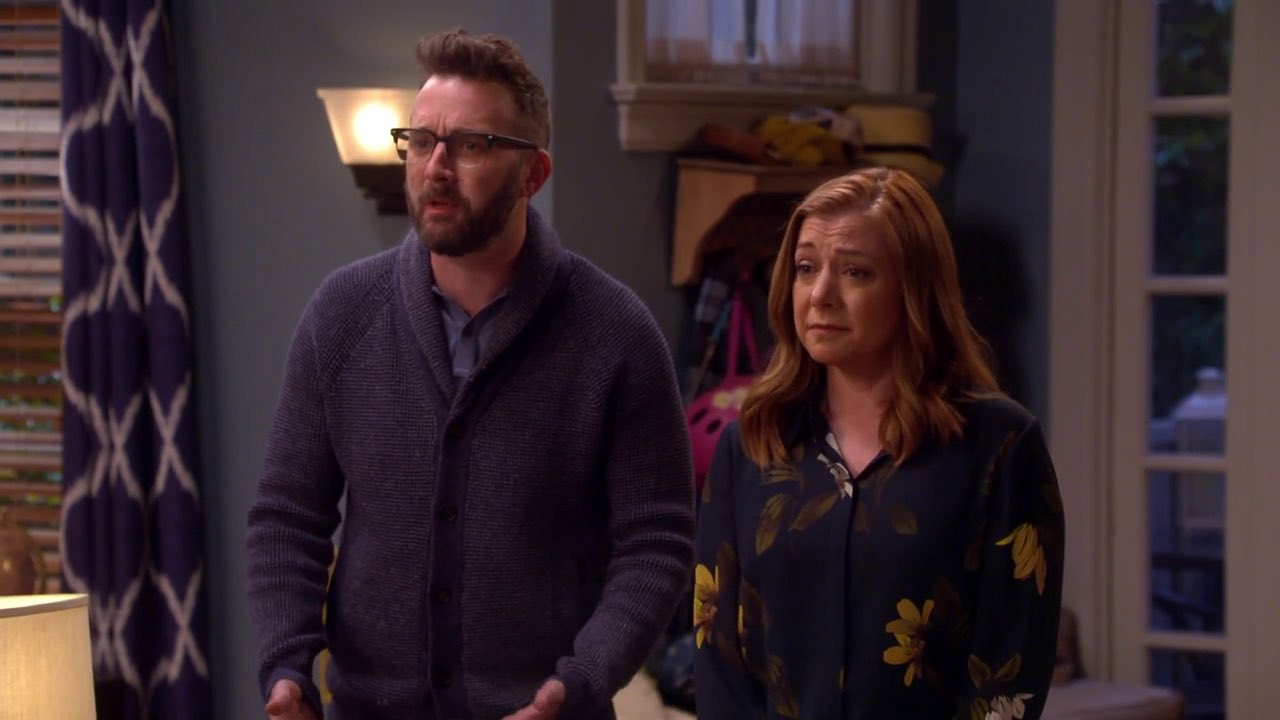What if they just found out they won a lottery? If the scenario was that they just found out they won a lottery, their concerned expressions could instead be interpreted as a mix of shock and disbelief. Perhaps they are trying to process the sudden life-changing news, unsure of what steps to take next, but aware that their lives will never be the sharegpt4v/same. Describe a realistic short scenario given this image. A realistic scenario might be the man and woman reacting to a loud noise outside their home, like a car accident or a sudden storm. They both naturally look towards the source of the noise, sharing a moment of unease as they consider what might have happened. Describe a realistic long scenario given this image. In a detailed, realistic scenario, the couple could be receiving troubling news on the phone about a loved one. The man, having just ended the call, is explaining the situation to the woman, both of them grappling with the implications of the news. This discussion might involve logistics about visiting the hospital, the condition of the person, and the emotional toll it takes on them. Their expressions convey the gravity of the situation as they try to support each other through this difficult moment, reinforcing their bond in times of hardship. 